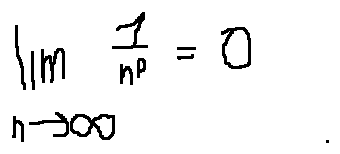<formula> <loc_0><loc_0><loc_500><loc_500>\lim \lim i t s _ { n \rightarrow \infty } \frac { 1 } { n ^ { p } } = 0</formula> 